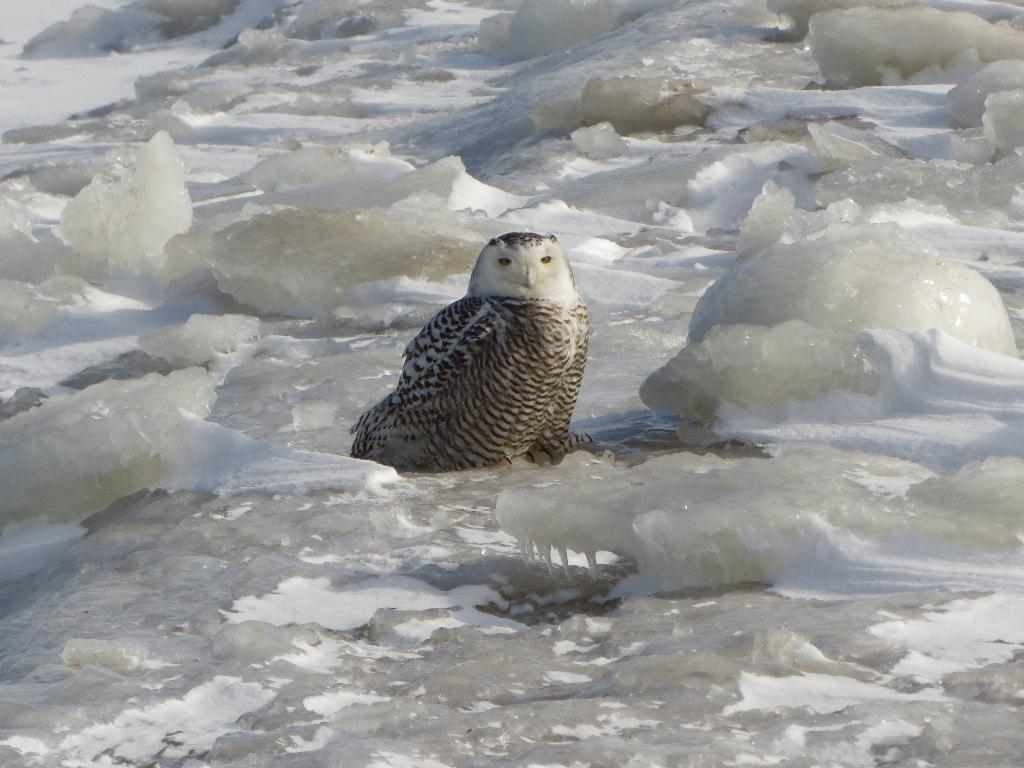What is the main subject of the image? There is a bird in the center of the center of the image. What can be seen in the background of the image? There is water and ice visible in the background of the image. Can you describe the bird's surroundings? The bird is surrounded by water and ice in the background. How many thumbs can be seen in the image? There are no thumbs present in the image. What type of sorting is the bird doing in the image? The bird is not shown sorting anything in the image. 